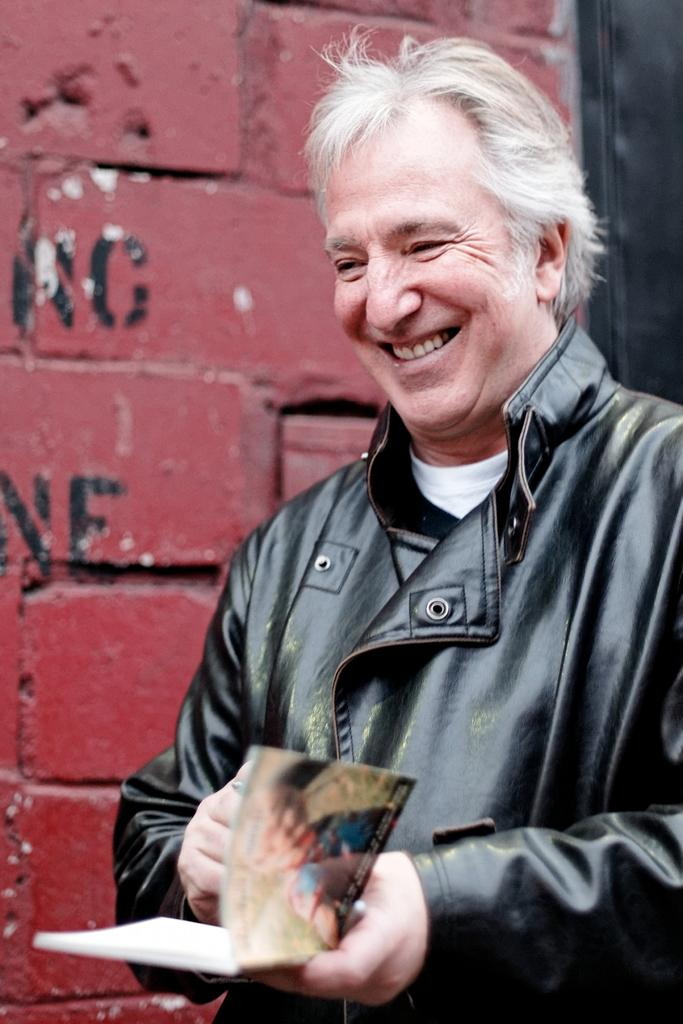What is the man in the picture doing? The man is standing and holding a book in his hands. What is the man wearing in the picture? The man is wearing a black color jacket. How is the man's facial expression in the picture? The man has a smile on his face. What can be seen in the background of the picture? There is a wall in the background of the picture. What is written or depicted on the wall? There is text on the wall. What type of jelly is the man eating in the picture? There is no jelly present in the image; the man is holding a book. What instrument is the man playing in the picture? There is no instrument present in the picture; the man is holding a book. 